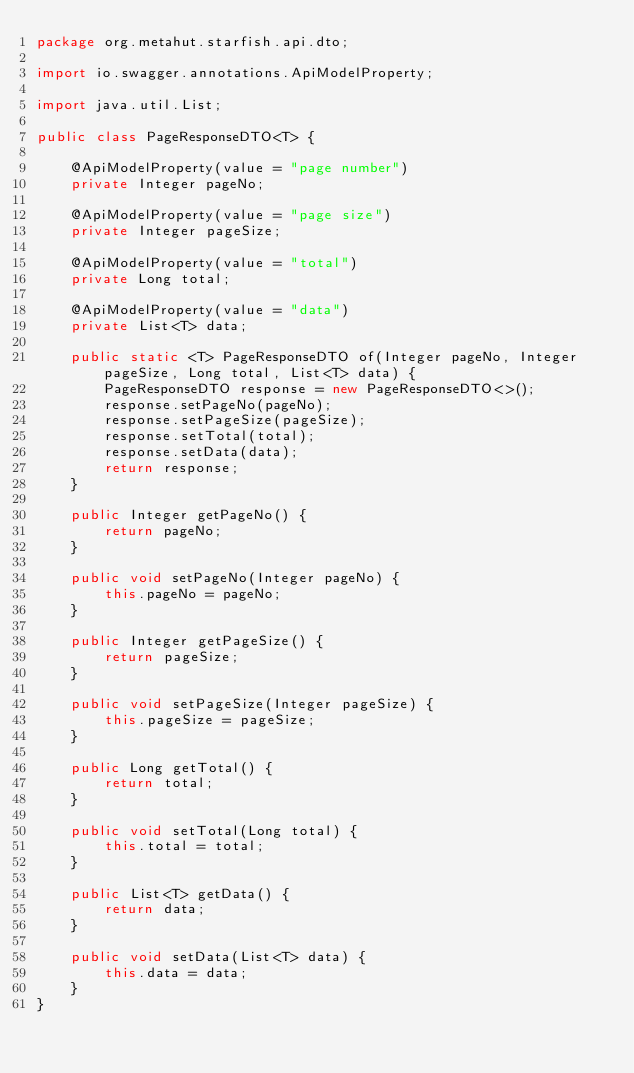Convert code to text. <code><loc_0><loc_0><loc_500><loc_500><_Java_>package org.metahut.starfish.api.dto;

import io.swagger.annotations.ApiModelProperty;

import java.util.List;

public class PageResponseDTO<T> {

    @ApiModelProperty(value = "page number")
    private Integer pageNo;

    @ApiModelProperty(value = "page size")
    private Integer pageSize;

    @ApiModelProperty(value = "total")
    private Long total;

    @ApiModelProperty(value = "data")
    private List<T> data;

    public static <T> PageResponseDTO of(Integer pageNo, Integer pageSize, Long total, List<T> data) {
        PageResponseDTO response = new PageResponseDTO<>();
        response.setPageNo(pageNo);
        response.setPageSize(pageSize);
        response.setTotal(total);
        response.setData(data);
        return response;
    }

    public Integer getPageNo() {
        return pageNo;
    }

    public void setPageNo(Integer pageNo) {
        this.pageNo = pageNo;
    }

    public Integer getPageSize() {
        return pageSize;
    }

    public void setPageSize(Integer pageSize) {
        this.pageSize = pageSize;
    }

    public Long getTotal() {
        return total;
    }

    public void setTotal(Long total) {
        this.total = total;
    }

    public List<T> getData() {
        return data;
    }

    public void setData(List<T> data) {
        this.data = data;
    }
}
</code> 